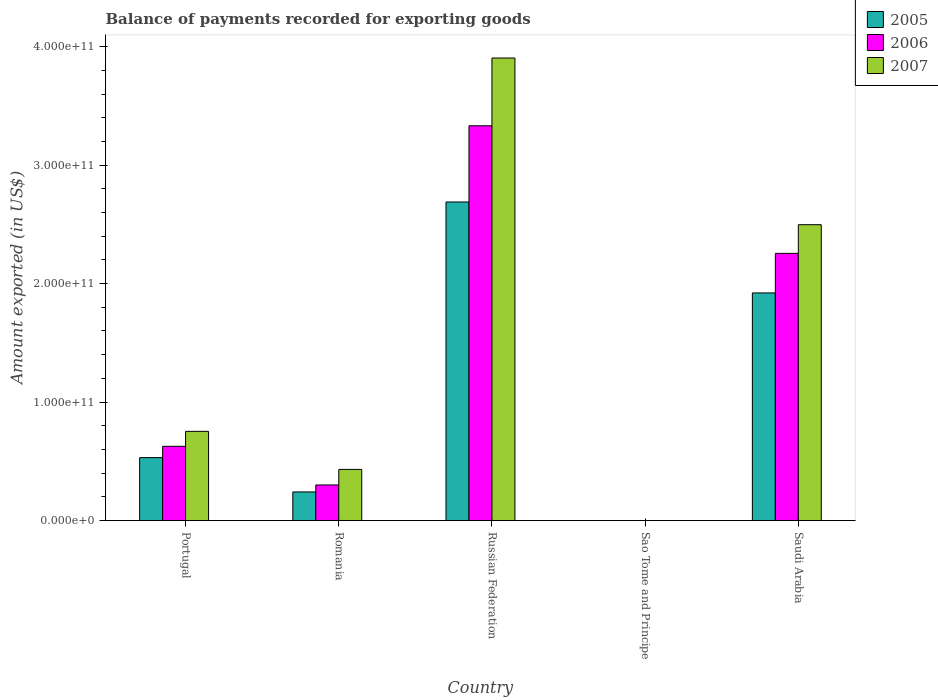How many different coloured bars are there?
Provide a succinct answer. 3. How many groups of bars are there?
Ensure brevity in your answer.  5. Are the number of bars on each tick of the X-axis equal?
Ensure brevity in your answer.  Yes. How many bars are there on the 5th tick from the left?
Offer a very short reply. 3. How many bars are there on the 1st tick from the right?
Ensure brevity in your answer.  3. What is the label of the 2nd group of bars from the left?
Offer a very short reply. Romania. What is the amount exported in 2007 in Russian Federation?
Offer a terse response. 3.90e+11. Across all countries, what is the maximum amount exported in 2006?
Keep it short and to the point. 3.33e+11. Across all countries, what is the minimum amount exported in 2007?
Your response must be concise. 1.35e+07. In which country was the amount exported in 2005 maximum?
Provide a short and direct response. Russian Federation. In which country was the amount exported in 2007 minimum?
Offer a very short reply. Sao Tome and Principe. What is the total amount exported in 2007 in the graph?
Offer a terse response. 7.59e+11. What is the difference between the amount exported in 2007 in Portugal and that in Sao Tome and Principe?
Ensure brevity in your answer.  7.53e+1. What is the difference between the amount exported in 2005 in Romania and the amount exported in 2006 in Portugal?
Offer a very short reply. -3.85e+1. What is the average amount exported in 2007 per country?
Provide a short and direct response. 1.52e+11. What is the difference between the amount exported of/in 2006 and amount exported of/in 2005 in Sao Tome and Principe?
Offer a very short reply. 1.71e+05. What is the ratio of the amount exported in 2006 in Romania to that in Saudi Arabia?
Your response must be concise. 0.13. Is the amount exported in 2006 in Portugal less than that in Russian Federation?
Your answer should be compact. Yes. What is the difference between the highest and the second highest amount exported in 2005?
Make the answer very short. 2.16e+11. What is the difference between the highest and the lowest amount exported in 2006?
Provide a succinct answer. 3.33e+11. Are all the bars in the graph horizontal?
Provide a short and direct response. No. What is the difference between two consecutive major ticks on the Y-axis?
Keep it short and to the point. 1.00e+11. Are the values on the major ticks of Y-axis written in scientific E-notation?
Provide a succinct answer. Yes. Does the graph contain any zero values?
Offer a terse response. No. Does the graph contain grids?
Offer a very short reply. No. Where does the legend appear in the graph?
Your response must be concise. Top right. How many legend labels are there?
Keep it short and to the point. 3. What is the title of the graph?
Make the answer very short. Balance of payments recorded for exporting goods. Does "1970" appear as one of the legend labels in the graph?
Your response must be concise. No. What is the label or title of the X-axis?
Your response must be concise. Country. What is the label or title of the Y-axis?
Make the answer very short. Amount exported (in US$). What is the Amount exported (in US$) in 2005 in Portugal?
Your answer should be very brief. 5.31e+1. What is the Amount exported (in US$) of 2006 in Portugal?
Make the answer very short. 6.27e+1. What is the Amount exported (in US$) of 2007 in Portugal?
Your answer should be very brief. 7.53e+1. What is the Amount exported (in US$) in 2005 in Romania?
Keep it short and to the point. 2.42e+1. What is the Amount exported (in US$) of 2006 in Romania?
Provide a succinct answer. 3.01e+1. What is the Amount exported (in US$) in 2007 in Romania?
Offer a very short reply. 4.32e+1. What is the Amount exported (in US$) in 2005 in Russian Federation?
Your answer should be compact. 2.69e+11. What is the Amount exported (in US$) of 2006 in Russian Federation?
Provide a short and direct response. 3.33e+11. What is the Amount exported (in US$) in 2007 in Russian Federation?
Offer a terse response. 3.90e+11. What is the Amount exported (in US$) in 2005 in Sao Tome and Principe?
Give a very brief answer. 1.59e+07. What is the Amount exported (in US$) in 2006 in Sao Tome and Principe?
Offer a very short reply. 1.61e+07. What is the Amount exported (in US$) of 2007 in Sao Tome and Principe?
Keep it short and to the point. 1.35e+07. What is the Amount exported (in US$) in 2005 in Saudi Arabia?
Provide a succinct answer. 1.92e+11. What is the Amount exported (in US$) of 2006 in Saudi Arabia?
Your answer should be compact. 2.26e+11. What is the Amount exported (in US$) in 2007 in Saudi Arabia?
Provide a succinct answer. 2.50e+11. Across all countries, what is the maximum Amount exported (in US$) of 2005?
Ensure brevity in your answer.  2.69e+11. Across all countries, what is the maximum Amount exported (in US$) in 2006?
Keep it short and to the point. 3.33e+11. Across all countries, what is the maximum Amount exported (in US$) of 2007?
Keep it short and to the point. 3.90e+11. Across all countries, what is the minimum Amount exported (in US$) of 2005?
Provide a short and direct response. 1.59e+07. Across all countries, what is the minimum Amount exported (in US$) of 2006?
Ensure brevity in your answer.  1.61e+07. Across all countries, what is the minimum Amount exported (in US$) of 2007?
Your answer should be very brief. 1.35e+07. What is the total Amount exported (in US$) in 2005 in the graph?
Keep it short and to the point. 5.38e+11. What is the total Amount exported (in US$) in 2006 in the graph?
Offer a terse response. 6.51e+11. What is the total Amount exported (in US$) of 2007 in the graph?
Your answer should be compact. 7.59e+11. What is the difference between the Amount exported (in US$) of 2005 in Portugal and that in Romania?
Provide a short and direct response. 2.90e+1. What is the difference between the Amount exported (in US$) in 2006 in Portugal and that in Romania?
Provide a short and direct response. 3.26e+1. What is the difference between the Amount exported (in US$) of 2007 in Portugal and that in Romania?
Provide a short and direct response. 3.21e+1. What is the difference between the Amount exported (in US$) in 2005 in Portugal and that in Russian Federation?
Offer a very short reply. -2.16e+11. What is the difference between the Amount exported (in US$) of 2006 in Portugal and that in Russian Federation?
Ensure brevity in your answer.  -2.71e+11. What is the difference between the Amount exported (in US$) in 2007 in Portugal and that in Russian Federation?
Offer a very short reply. -3.15e+11. What is the difference between the Amount exported (in US$) of 2005 in Portugal and that in Sao Tome and Principe?
Give a very brief answer. 5.31e+1. What is the difference between the Amount exported (in US$) of 2006 in Portugal and that in Sao Tome and Principe?
Your response must be concise. 6.27e+1. What is the difference between the Amount exported (in US$) of 2007 in Portugal and that in Sao Tome and Principe?
Your response must be concise. 7.53e+1. What is the difference between the Amount exported (in US$) of 2005 in Portugal and that in Saudi Arabia?
Make the answer very short. -1.39e+11. What is the difference between the Amount exported (in US$) in 2006 in Portugal and that in Saudi Arabia?
Your response must be concise. -1.63e+11. What is the difference between the Amount exported (in US$) of 2007 in Portugal and that in Saudi Arabia?
Provide a short and direct response. -1.74e+11. What is the difference between the Amount exported (in US$) in 2005 in Romania and that in Russian Federation?
Ensure brevity in your answer.  -2.45e+11. What is the difference between the Amount exported (in US$) of 2006 in Romania and that in Russian Federation?
Keep it short and to the point. -3.03e+11. What is the difference between the Amount exported (in US$) in 2007 in Romania and that in Russian Federation?
Provide a succinct answer. -3.47e+11. What is the difference between the Amount exported (in US$) in 2005 in Romania and that in Sao Tome and Principe?
Offer a terse response. 2.41e+1. What is the difference between the Amount exported (in US$) in 2006 in Romania and that in Sao Tome and Principe?
Provide a short and direct response. 3.00e+1. What is the difference between the Amount exported (in US$) of 2007 in Romania and that in Sao Tome and Principe?
Give a very brief answer. 4.32e+1. What is the difference between the Amount exported (in US$) in 2005 in Romania and that in Saudi Arabia?
Offer a very short reply. -1.68e+11. What is the difference between the Amount exported (in US$) in 2006 in Romania and that in Saudi Arabia?
Keep it short and to the point. -1.95e+11. What is the difference between the Amount exported (in US$) in 2007 in Romania and that in Saudi Arabia?
Keep it short and to the point. -2.07e+11. What is the difference between the Amount exported (in US$) in 2005 in Russian Federation and that in Sao Tome and Principe?
Give a very brief answer. 2.69e+11. What is the difference between the Amount exported (in US$) of 2006 in Russian Federation and that in Sao Tome and Principe?
Your answer should be very brief. 3.33e+11. What is the difference between the Amount exported (in US$) of 2007 in Russian Federation and that in Sao Tome and Principe?
Ensure brevity in your answer.  3.90e+11. What is the difference between the Amount exported (in US$) in 2005 in Russian Federation and that in Saudi Arabia?
Offer a terse response. 7.67e+1. What is the difference between the Amount exported (in US$) in 2006 in Russian Federation and that in Saudi Arabia?
Your answer should be very brief. 1.08e+11. What is the difference between the Amount exported (in US$) of 2007 in Russian Federation and that in Saudi Arabia?
Provide a succinct answer. 1.41e+11. What is the difference between the Amount exported (in US$) in 2005 in Sao Tome and Principe and that in Saudi Arabia?
Make the answer very short. -1.92e+11. What is the difference between the Amount exported (in US$) of 2006 in Sao Tome and Principe and that in Saudi Arabia?
Your answer should be very brief. -2.25e+11. What is the difference between the Amount exported (in US$) of 2007 in Sao Tome and Principe and that in Saudi Arabia?
Ensure brevity in your answer.  -2.50e+11. What is the difference between the Amount exported (in US$) in 2005 in Portugal and the Amount exported (in US$) in 2006 in Romania?
Make the answer very short. 2.31e+1. What is the difference between the Amount exported (in US$) of 2005 in Portugal and the Amount exported (in US$) of 2007 in Romania?
Ensure brevity in your answer.  9.94e+09. What is the difference between the Amount exported (in US$) in 2006 in Portugal and the Amount exported (in US$) in 2007 in Romania?
Your response must be concise. 1.95e+1. What is the difference between the Amount exported (in US$) in 2005 in Portugal and the Amount exported (in US$) in 2006 in Russian Federation?
Your answer should be compact. -2.80e+11. What is the difference between the Amount exported (in US$) in 2005 in Portugal and the Amount exported (in US$) in 2007 in Russian Federation?
Your answer should be compact. -3.37e+11. What is the difference between the Amount exported (in US$) of 2006 in Portugal and the Amount exported (in US$) of 2007 in Russian Federation?
Ensure brevity in your answer.  -3.28e+11. What is the difference between the Amount exported (in US$) in 2005 in Portugal and the Amount exported (in US$) in 2006 in Sao Tome and Principe?
Provide a short and direct response. 5.31e+1. What is the difference between the Amount exported (in US$) in 2005 in Portugal and the Amount exported (in US$) in 2007 in Sao Tome and Principe?
Ensure brevity in your answer.  5.31e+1. What is the difference between the Amount exported (in US$) of 2006 in Portugal and the Amount exported (in US$) of 2007 in Sao Tome and Principe?
Your answer should be very brief. 6.27e+1. What is the difference between the Amount exported (in US$) of 2005 in Portugal and the Amount exported (in US$) of 2006 in Saudi Arabia?
Keep it short and to the point. -1.72e+11. What is the difference between the Amount exported (in US$) in 2005 in Portugal and the Amount exported (in US$) in 2007 in Saudi Arabia?
Make the answer very short. -1.97e+11. What is the difference between the Amount exported (in US$) of 2006 in Portugal and the Amount exported (in US$) of 2007 in Saudi Arabia?
Keep it short and to the point. -1.87e+11. What is the difference between the Amount exported (in US$) of 2005 in Romania and the Amount exported (in US$) of 2006 in Russian Federation?
Your answer should be very brief. -3.09e+11. What is the difference between the Amount exported (in US$) in 2005 in Romania and the Amount exported (in US$) in 2007 in Russian Federation?
Your answer should be very brief. -3.66e+11. What is the difference between the Amount exported (in US$) in 2006 in Romania and the Amount exported (in US$) in 2007 in Russian Federation?
Offer a very short reply. -3.60e+11. What is the difference between the Amount exported (in US$) of 2005 in Romania and the Amount exported (in US$) of 2006 in Sao Tome and Principe?
Your answer should be very brief. 2.41e+1. What is the difference between the Amount exported (in US$) of 2005 in Romania and the Amount exported (in US$) of 2007 in Sao Tome and Principe?
Your response must be concise. 2.41e+1. What is the difference between the Amount exported (in US$) of 2006 in Romania and the Amount exported (in US$) of 2007 in Sao Tome and Principe?
Give a very brief answer. 3.01e+1. What is the difference between the Amount exported (in US$) in 2005 in Romania and the Amount exported (in US$) in 2006 in Saudi Arabia?
Provide a succinct answer. -2.01e+11. What is the difference between the Amount exported (in US$) of 2005 in Romania and the Amount exported (in US$) of 2007 in Saudi Arabia?
Provide a succinct answer. -2.26e+11. What is the difference between the Amount exported (in US$) of 2006 in Romania and the Amount exported (in US$) of 2007 in Saudi Arabia?
Your response must be concise. -2.20e+11. What is the difference between the Amount exported (in US$) in 2005 in Russian Federation and the Amount exported (in US$) in 2006 in Sao Tome and Principe?
Give a very brief answer. 2.69e+11. What is the difference between the Amount exported (in US$) in 2005 in Russian Federation and the Amount exported (in US$) in 2007 in Sao Tome and Principe?
Offer a terse response. 2.69e+11. What is the difference between the Amount exported (in US$) of 2006 in Russian Federation and the Amount exported (in US$) of 2007 in Sao Tome and Principe?
Ensure brevity in your answer.  3.33e+11. What is the difference between the Amount exported (in US$) in 2005 in Russian Federation and the Amount exported (in US$) in 2006 in Saudi Arabia?
Your answer should be very brief. 4.34e+1. What is the difference between the Amount exported (in US$) in 2005 in Russian Federation and the Amount exported (in US$) in 2007 in Saudi Arabia?
Ensure brevity in your answer.  1.92e+1. What is the difference between the Amount exported (in US$) in 2006 in Russian Federation and the Amount exported (in US$) in 2007 in Saudi Arabia?
Your response must be concise. 8.35e+1. What is the difference between the Amount exported (in US$) in 2005 in Sao Tome and Principe and the Amount exported (in US$) in 2006 in Saudi Arabia?
Keep it short and to the point. -2.25e+11. What is the difference between the Amount exported (in US$) of 2005 in Sao Tome and Principe and the Amount exported (in US$) of 2007 in Saudi Arabia?
Your response must be concise. -2.50e+11. What is the difference between the Amount exported (in US$) of 2006 in Sao Tome and Principe and the Amount exported (in US$) of 2007 in Saudi Arabia?
Provide a succinct answer. -2.50e+11. What is the average Amount exported (in US$) in 2005 per country?
Provide a short and direct response. 1.08e+11. What is the average Amount exported (in US$) in 2006 per country?
Keep it short and to the point. 1.30e+11. What is the average Amount exported (in US$) in 2007 per country?
Give a very brief answer. 1.52e+11. What is the difference between the Amount exported (in US$) in 2005 and Amount exported (in US$) in 2006 in Portugal?
Provide a short and direct response. -9.54e+09. What is the difference between the Amount exported (in US$) of 2005 and Amount exported (in US$) of 2007 in Portugal?
Give a very brief answer. -2.22e+1. What is the difference between the Amount exported (in US$) in 2006 and Amount exported (in US$) in 2007 in Portugal?
Make the answer very short. -1.26e+1. What is the difference between the Amount exported (in US$) in 2005 and Amount exported (in US$) in 2006 in Romania?
Provide a succinct answer. -5.90e+09. What is the difference between the Amount exported (in US$) of 2005 and Amount exported (in US$) of 2007 in Romania?
Give a very brief answer. -1.90e+1. What is the difference between the Amount exported (in US$) of 2006 and Amount exported (in US$) of 2007 in Romania?
Your answer should be compact. -1.31e+1. What is the difference between the Amount exported (in US$) of 2005 and Amount exported (in US$) of 2006 in Russian Federation?
Make the answer very short. -6.43e+1. What is the difference between the Amount exported (in US$) of 2005 and Amount exported (in US$) of 2007 in Russian Federation?
Make the answer very short. -1.22e+11. What is the difference between the Amount exported (in US$) in 2006 and Amount exported (in US$) in 2007 in Russian Federation?
Provide a succinct answer. -5.72e+1. What is the difference between the Amount exported (in US$) of 2005 and Amount exported (in US$) of 2006 in Sao Tome and Principe?
Keep it short and to the point. -1.71e+05. What is the difference between the Amount exported (in US$) in 2005 and Amount exported (in US$) in 2007 in Sao Tome and Principe?
Your answer should be very brief. 2.43e+06. What is the difference between the Amount exported (in US$) in 2006 and Amount exported (in US$) in 2007 in Sao Tome and Principe?
Keep it short and to the point. 2.60e+06. What is the difference between the Amount exported (in US$) in 2005 and Amount exported (in US$) in 2006 in Saudi Arabia?
Offer a very short reply. -3.34e+1. What is the difference between the Amount exported (in US$) of 2005 and Amount exported (in US$) of 2007 in Saudi Arabia?
Give a very brief answer. -5.76e+1. What is the difference between the Amount exported (in US$) in 2006 and Amount exported (in US$) in 2007 in Saudi Arabia?
Keep it short and to the point. -2.42e+1. What is the ratio of the Amount exported (in US$) in 2005 in Portugal to that in Romania?
Provide a succinct answer. 2.2. What is the ratio of the Amount exported (in US$) in 2006 in Portugal to that in Romania?
Offer a very short reply. 2.08. What is the ratio of the Amount exported (in US$) of 2007 in Portugal to that in Romania?
Provide a short and direct response. 1.74. What is the ratio of the Amount exported (in US$) in 2005 in Portugal to that in Russian Federation?
Offer a terse response. 0.2. What is the ratio of the Amount exported (in US$) in 2006 in Portugal to that in Russian Federation?
Provide a succinct answer. 0.19. What is the ratio of the Amount exported (in US$) in 2007 in Portugal to that in Russian Federation?
Your answer should be very brief. 0.19. What is the ratio of the Amount exported (in US$) in 2005 in Portugal to that in Sao Tome and Principe?
Ensure brevity in your answer.  3331.85. What is the ratio of the Amount exported (in US$) of 2006 in Portugal to that in Sao Tome and Principe?
Provide a short and direct response. 3888.88. What is the ratio of the Amount exported (in US$) in 2007 in Portugal to that in Sao Tome and Principe?
Your answer should be compact. 5573.79. What is the ratio of the Amount exported (in US$) of 2005 in Portugal to that in Saudi Arabia?
Give a very brief answer. 0.28. What is the ratio of the Amount exported (in US$) in 2006 in Portugal to that in Saudi Arabia?
Your response must be concise. 0.28. What is the ratio of the Amount exported (in US$) of 2007 in Portugal to that in Saudi Arabia?
Your answer should be compact. 0.3. What is the ratio of the Amount exported (in US$) of 2005 in Romania to that in Russian Federation?
Your answer should be compact. 0.09. What is the ratio of the Amount exported (in US$) in 2006 in Romania to that in Russian Federation?
Give a very brief answer. 0.09. What is the ratio of the Amount exported (in US$) of 2007 in Romania to that in Russian Federation?
Provide a succinct answer. 0.11. What is the ratio of the Amount exported (in US$) in 2005 in Romania to that in Sao Tome and Principe?
Make the answer very short. 1515.3. What is the ratio of the Amount exported (in US$) of 2006 in Romania to that in Sao Tome and Principe?
Make the answer very short. 1865.6. What is the ratio of the Amount exported (in US$) in 2007 in Romania to that in Sao Tome and Principe?
Give a very brief answer. 3196.6. What is the ratio of the Amount exported (in US$) of 2005 in Romania to that in Saudi Arabia?
Ensure brevity in your answer.  0.13. What is the ratio of the Amount exported (in US$) in 2006 in Romania to that in Saudi Arabia?
Provide a short and direct response. 0.13. What is the ratio of the Amount exported (in US$) in 2007 in Romania to that in Saudi Arabia?
Offer a terse response. 0.17. What is the ratio of the Amount exported (in US$) in 2005 in Russian Federation to that in Sao Tome and Principe?
Your answer should be very brief. 1.69e+04. What is the ratio of the Amount exported (in US$) of 2006 in Russian Federation to that in Sao Tome and Principe?
Your answer should be very brief. 2.07e+04. What is the ratio of the Amount exported (in US$) of 2007 in Russian Federation to that in Sao Tome and Principe?
Ensure brevity in your answer.  2.89e+04. What is the ratio of the Amount exported (in US$) of 2005 in Russian Federation to that in Saudi Arabia?
Your answer should be compact. 1.4. What is the ratio of the Amount exported (in US$) of 2006 in Russian Federation to that in Saudi Arabia?
Keep it short and to the point. 1.48. What is the ratio of the Amount exported (in US$) of 2007 in Russian Federation to that in Saudi Arabia?
Give a very brief answer. 1.56. What is the ratio of the Amount exported (in US$) in 2005 in Sao Tome and Principe to that in Saudi Arabia?
Offer a terse response. 0. What is the ratio of the Amount exported (in US$) in 2006 in Sao Tome and Principe to that in Saudi Arabia?
Keep it short and to the point. 0. What is the ratio of the Amount exported (in US$) of 2007 in Sao Tome and Principe to that in Saudi Arabia?
Your answer should be very brief. 0. What is the difference between the highest and the second highest Amount exported (in US$) in 2005?
Provide a succinct answer. 7.67e+1. What is the difference between the highest and the second highest Amount exported (in US$) of 2006?
Give a very brief answer. 1.08e+11. What is the difference between the highest and the second highest Amount exported (in US$) of 2007?
Make the answer very short. 1.41e+11. What is the difference between the highest and the lowest Amount exported (in US$) of 2005?
Your answer should be very brief. 2.69e+11. What is the difference between the highest and the lowest Amount exported (in US$) in 2006?
Give a very brief answer. 3.33e+11. What is the difference between the highest and the lowest Amount exported (in US$) in 2007?
Your response must be concise. 3.90e+11. 